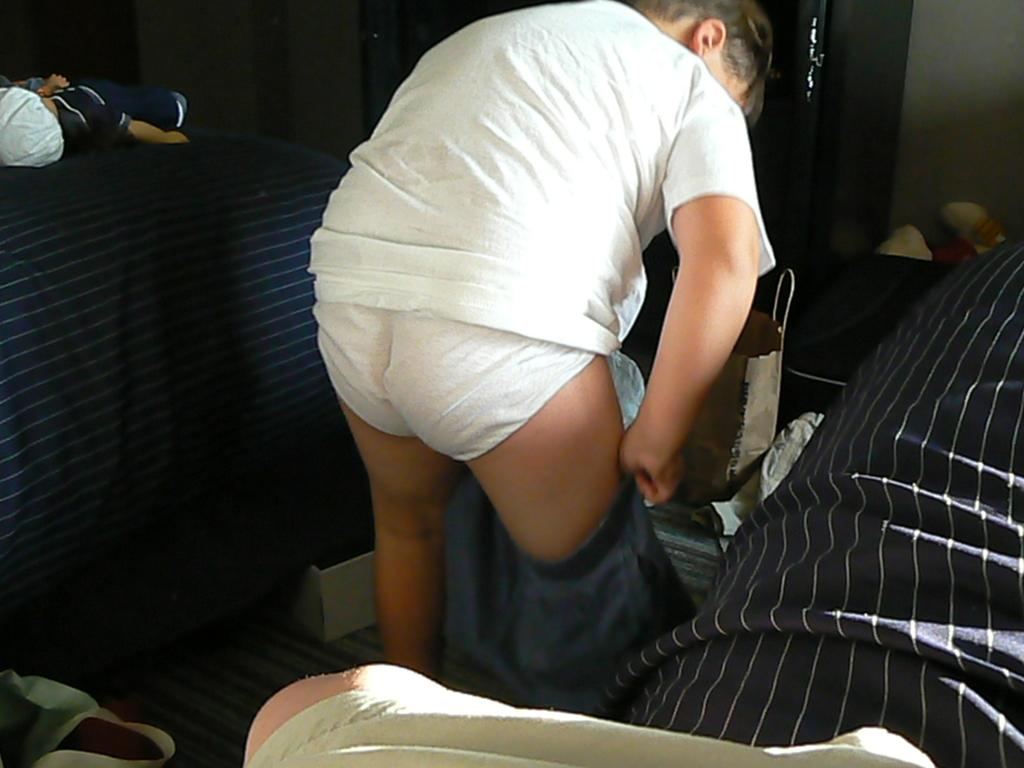What is the person wearing in the image? The person is wearing pants in the image. What part of the person's body is visible? The person's legs are visible in the image. What other items can be seen in the image? There are dolls, clothes, a wall in the background, a bag, a box, and objects on the floor in the image. How many children are holding cherries in the image? There are no children or cherries present in the image. What is the relation between the person and the dolls in the image? There is no information about the person's relation to the dolls in the image. 